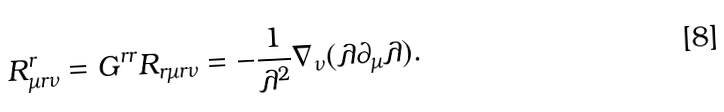<formula> <loc_0><loc_0><loc_500><loc_500>R _ { \mu r \nu } ^ { r } = G ^ { r r } R _ { r \mu r \nu } = - \frac { 1 } { \lambda ^ { 2 } } \nabla _ { \nu } ( \lambda \partial _ { \mu } \lambda ) .</formula> 